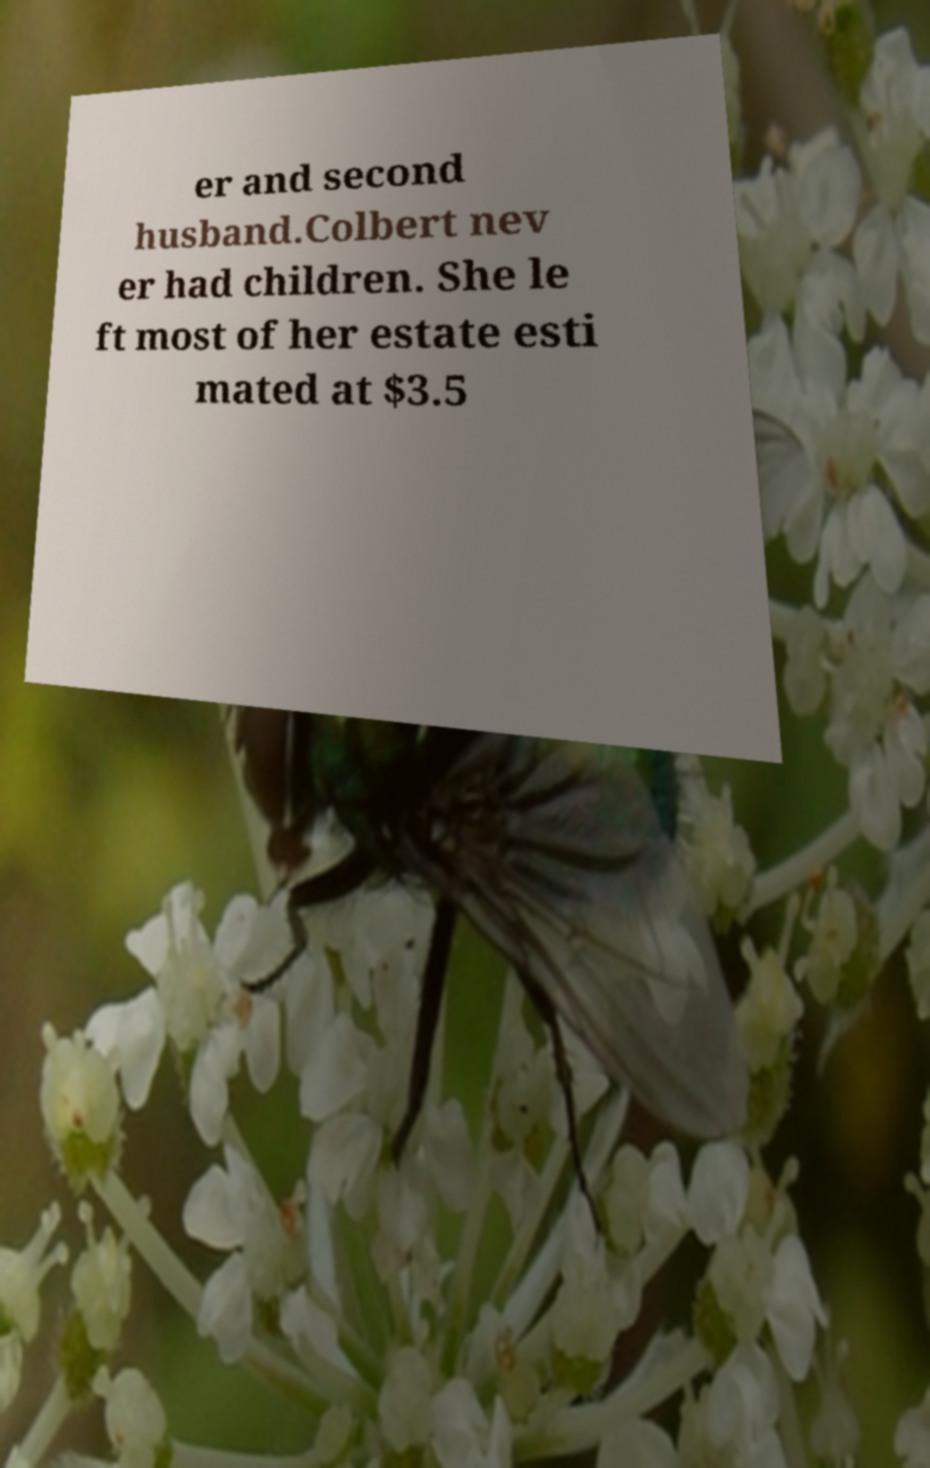Could you assist in decoding the text presented in this image and type it out clearly? er and second husband.Colbert nev er had children. She le ft most of her estate esti mated at $3.5 